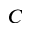<formula> <loc_0><loc_0><loc_500><loc_500>C</formula> 